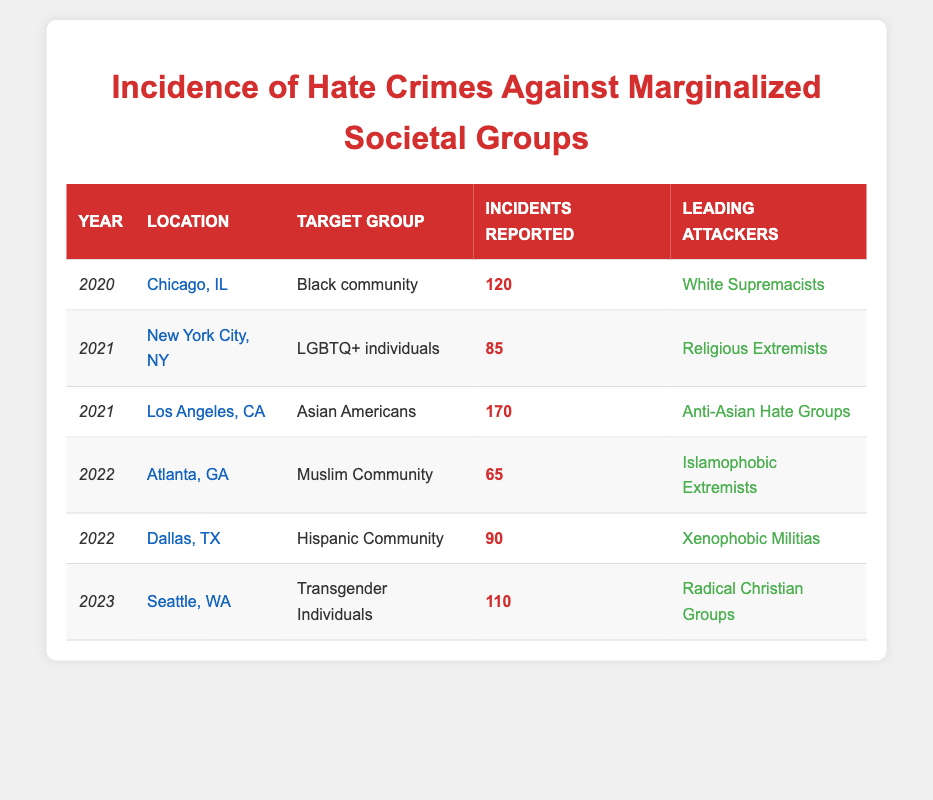What was the location with the highest number of reported hate crimes? By examining the "Incidents Reported" column for each location, Los Angeles, CA has the highest number of reported incidents at 170.
Answer: Los Angeles, CA How many incidents were reported against the Black community in 2020? The table shows that in 2020, there were 120 incidents reported against the Black community in Chicago, IL.
Answer: 120 Which target group experienced hate crimes in both 2021 and 2022? The target group "LGBTQ+ individuals" experienced hate crimes in 2021, and the "Muslim Community" experienced them in 2022, so no single group appears in both years.
Answer: No What is the total number of hate crime incidents reported from 2020 to 2023? Adding all reported incidents: 120 (2020) + 85 (2021) + 170 (2021) + 65 (2022) + 90 (2022) + 110 (2023) equals a total of 640 incidents.
Answer: 640 Did the Muslim Community experience more incidents in 2022 than the LGBTQ+ individuals in 2021? The Muslim Community had 65 incidents in 2022, while LGBTQ+ individuals had 85 incidents in 2021. Since 85 is greater than 65, the Muslim Community did not experience more incidents.
Answer: No What was the leading group of attackers in 2023, and how many incidents were reported? The leading attackers in 2023 were "Radical Christian Groups" with 110 incidents reported against Transgender Individuals.
Answer: Radical Christian Groups, 110 Which of the target groups had the least incidents reported, and what was the number? By checking the "Incidents Reported" column, the Muslim Community had the least incidents reported, with only 65 in 2022.
Answer: Muslim Community, 65 Was there an increase or decrease in reported incidents from 2020 to 2021? Comparing 2020 (120 incidents) to 2021: the total for 2021 (85 + 170) is 255, which indicates an increase from 120 to 255.
Answer: Increase How many incidents were reported against the Hispanic Community compared to the Asian Americans? The Hispanic Community had 90 incidents in Dallas, TX while Asian Americans had 170 incidents in Los Angeles, CA. Therefore, 90 is less than 170.
Answer: Asian Americans had more incidents 